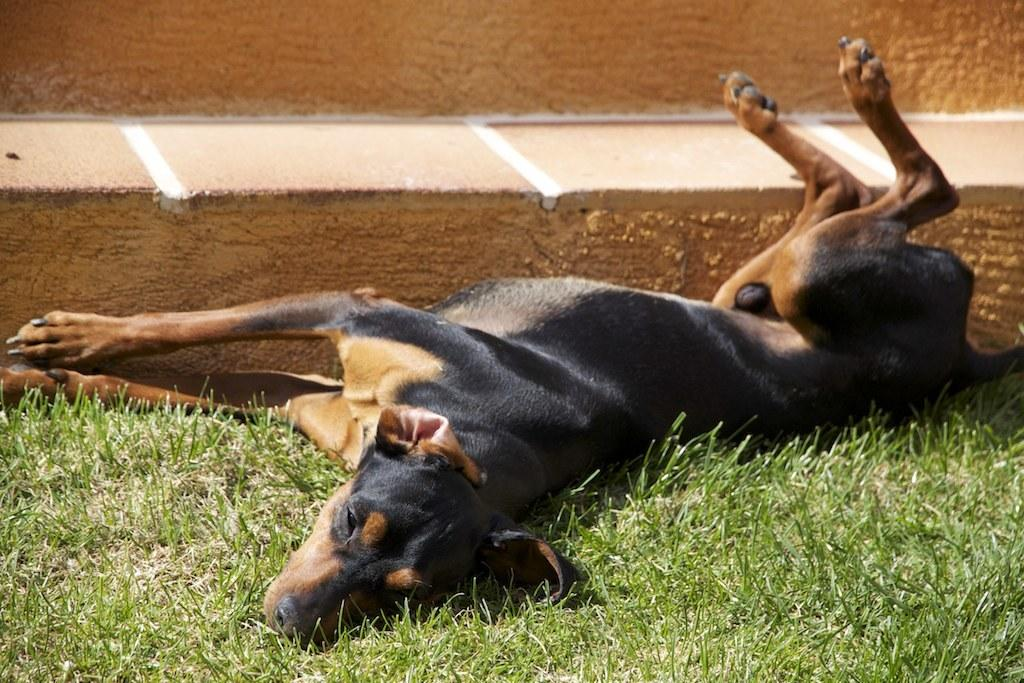What type of animal can be seen in the picture? There is a dog in the picture. What type of terrain is visible in the picture? There is grass and ground visible in the picture. What type of skin can be seen on the zebra in the picture? There is no zebra present in the picture; it features a dog. How many cars are visible in the picture? There are no cars visible in the picture; it features a dog in a grassy area. 